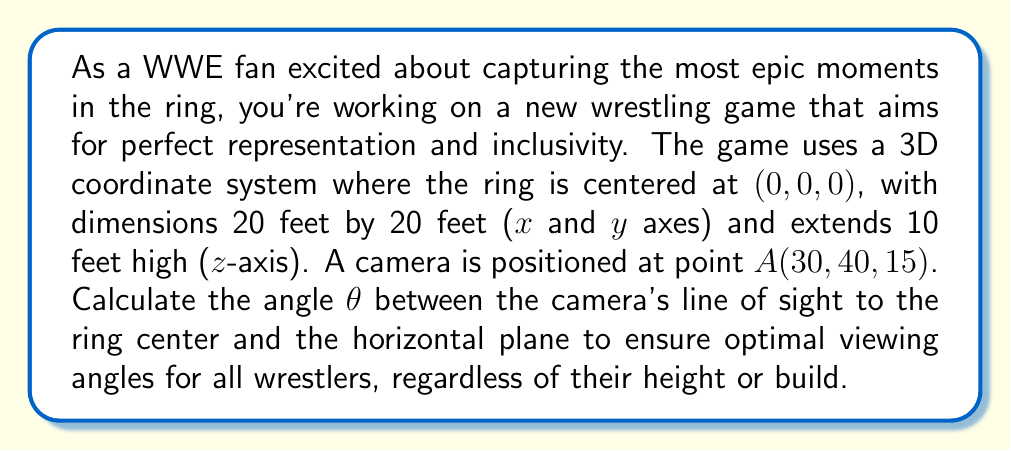Show me your answer to this math problem. To solve this problem, we'll use 3D trigonometry. Let's break it down step-by-step:

1) First, we need to find the horizontal distance from the camera to the ring center. We can do this using the Pythagorean theorem in the xy-plane:

   $$d_{xy} = \sqrt{30^2 + 40^2} = \sqrt{900 + 1600} = \sqrt{2500} = 50\text{ feet}$$

2) Now we have a right triangle in the xz-plane, where:
   - The adjacent side is the horizontal distance we just calculated (50 feet)
   - The opposite side is the height difference (15 feet, as the ring center is at z=0)
   - The hypotenuse is the direct line from the camera to the ring center

3) We can find the angle θ using the tangent function:

   $$\tan(\theta) = \frac{\text{opposite}}{\text{adjacent}} = \frac{15}{50}$$

4) To get θ, we need to take the inverse tangent (arctan or tan^(-1)):

   $$\theta = \tan^{-1}(\frac{15}{50})$$

5) Using a calculator or programming function, we can compute this value:

   $$\theta \approx 0.2915 \text{ radians}$$

6) Converting to degrees:

   $$\theta \approx 0.2915 \times \frac{180}{\pi} \approx 16.70°$$

This angle ensures that the camera captures the full vertical range of the ring, providing optimal viewing for all wrestlers regardless of their height or position in the ring.
Answer: The optimal angle θ between the camera's line of sight and the horizontal plane is approximately 16.70°. 